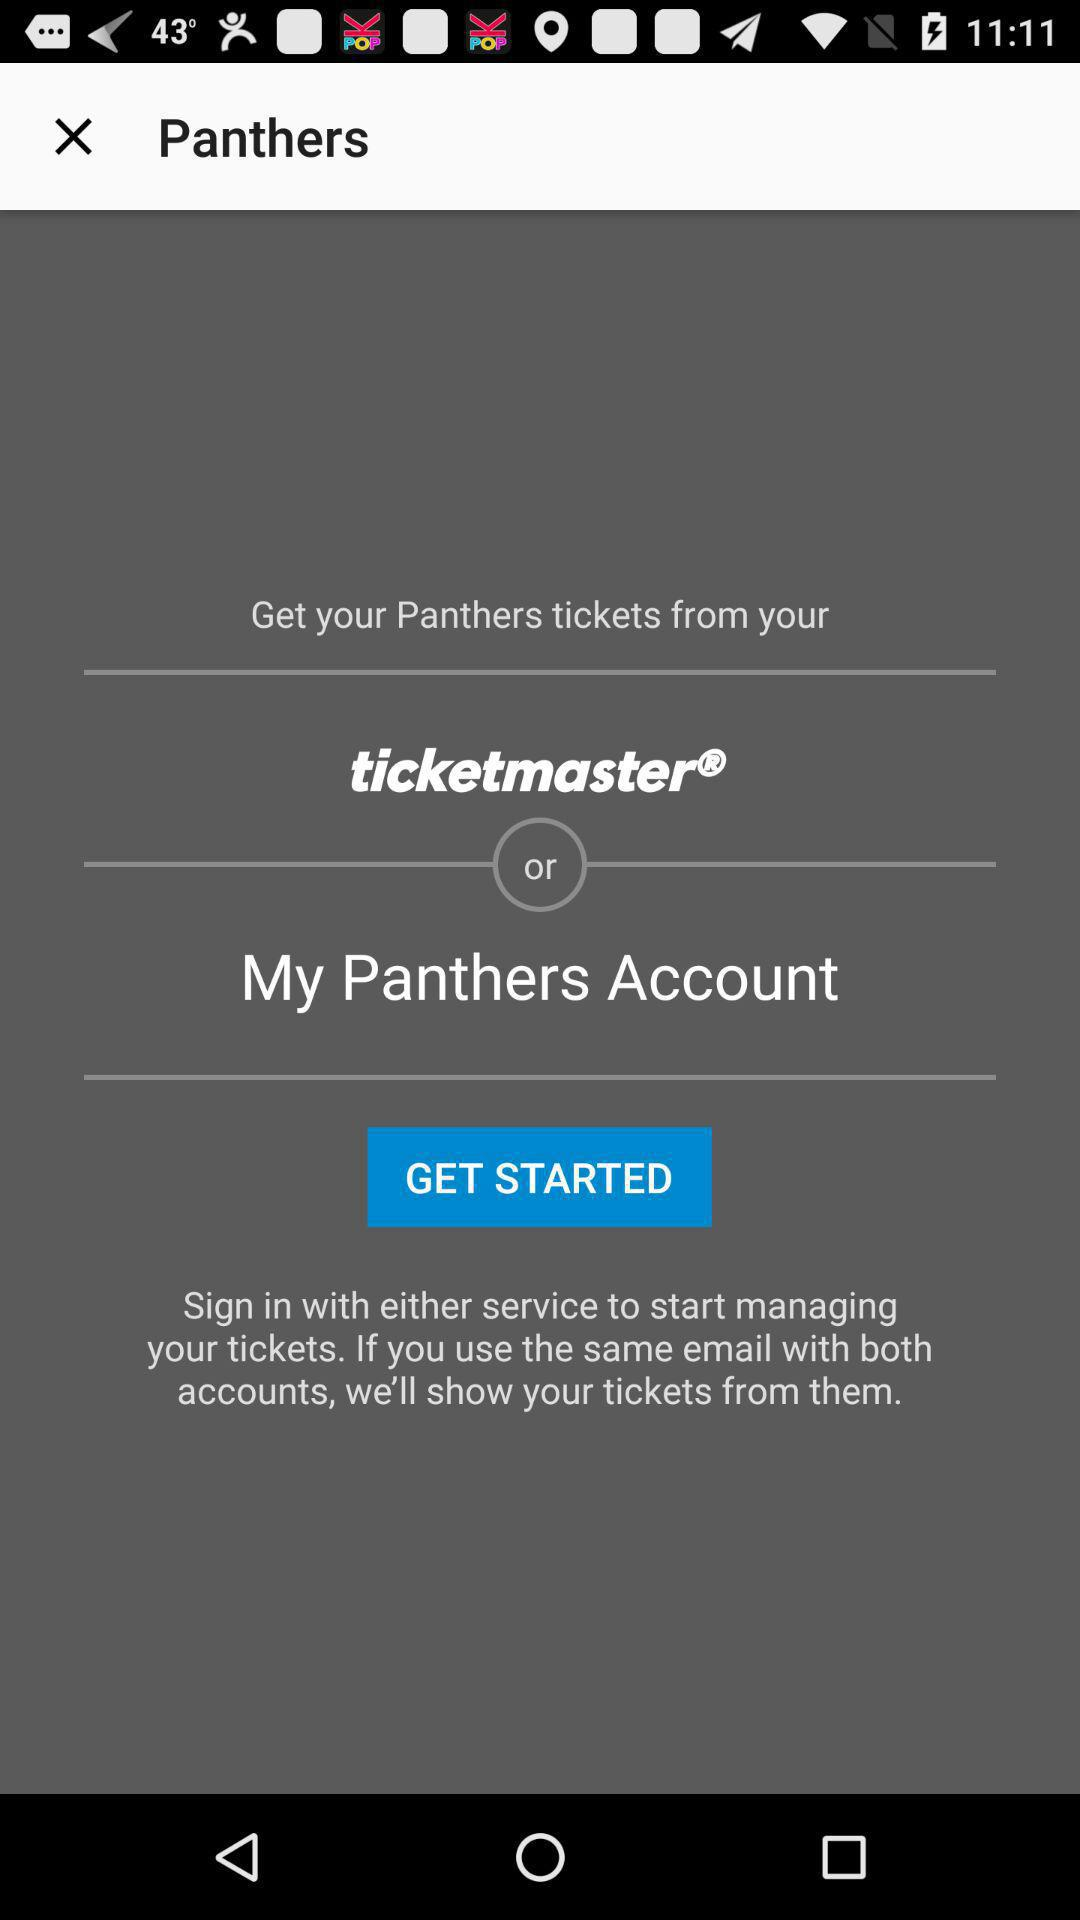How many services can I use to get my Panthers tickets?
Answer the question using a single word or phrase. 2 